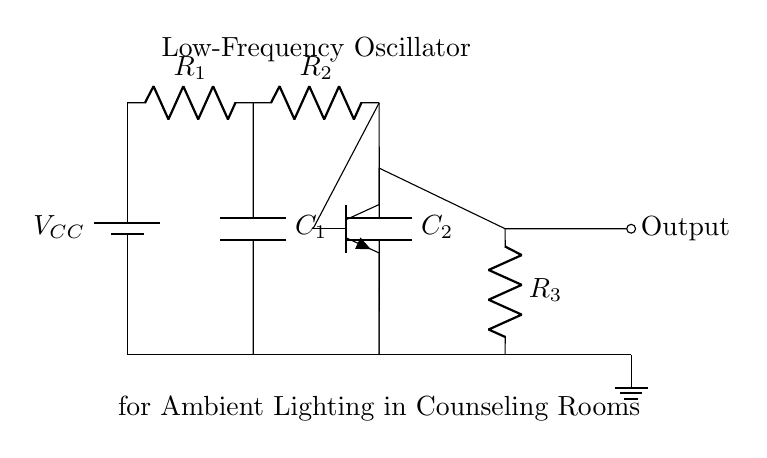What type of circuit is represented? This circuit is a low-frequency oscillator, which generates a periodic output signal. It is specifically designed for creating ambient lighting effects.
Answer: Low-Frequency Oscillator What are the main components used in the circuit? The main components are resistors, capacitors, a transistor, and a power supply. These components work together to create the oscillation necessary for the light effects.
Answer: Resistors, capacitors, transistor, power supply How many resistors are present in the circuit? The circuit has three resistors connected in a series-parallel configuration, which affects the time constant of the oscillator.
Answer: Three What is the purpose of the capacitors in this circuit? The capacitors are used to store and release energy, helping to determine the frequency and stability of the oscillation by charging and discharging at certain intervals.
Answer: Energy storage What role does the transistor play in this oscillator circuit? The transistor acts as a switch or amplifier in the oscillator circuit, controlling the flow of current and enabling the oscillation of the output signal.
Answer: Switch or amplifier How does the output relate to the ambient lighting effect? The output of the oscillator generates a varying voltage that can be used to control lights, creating dynamic ambient lighting that can be soothing in counseling rooms.
Answer: Dynamic ambient lighting 